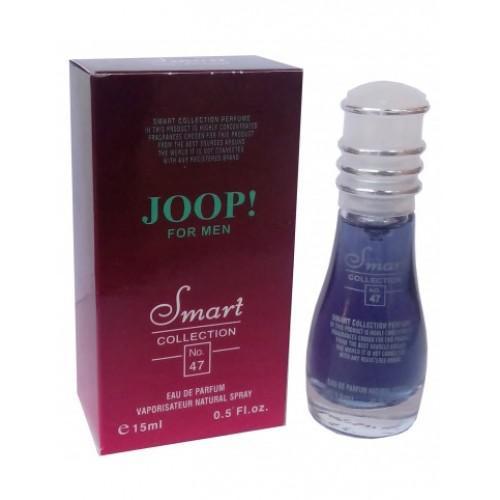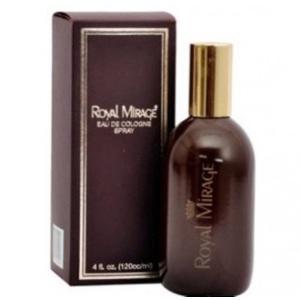The first image is the image on the left, the second image is the image on the right. Given the left and right images, does the statement "A square bottle of pale yellowish liquid stands to the right and slightly overlapping its box." hold true? Answer yes or no. No. 